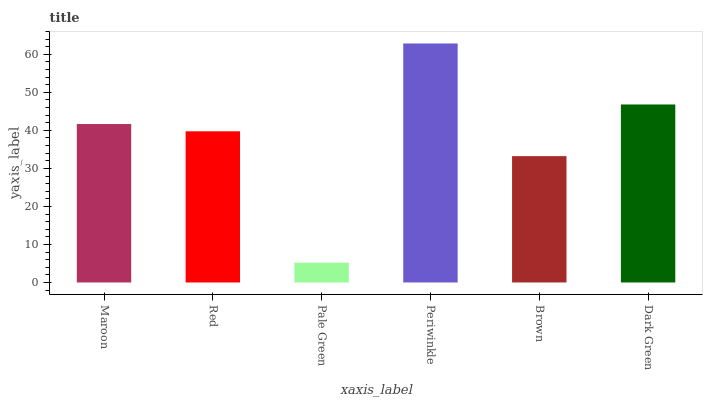Is Pale Green the minimum?
Answer yes or no. Yes. Is Periwinkle the maximum?
Answer yes or no. Yes. Is Red the minimum?
Answer yes or no. No. Is Red the maximum?
Answer yes or no. No. Is Maroon greater than Red?
Answer yes or no. Yes. Is Red less than Maroon?
Answer yes or no. Yes. Is Red greater than Maroon?
Answer yes or no. No. Is Maroon less than Red?
Answer yes or no. No. Is Maroon the high median?
Answer yes or no. Yes. Is Red the low median?
Answer yes or no. Yes. Is Brown the high median?
Answer yes or no. No. Is Pale Green the low median?
Answer yes or no. No. 